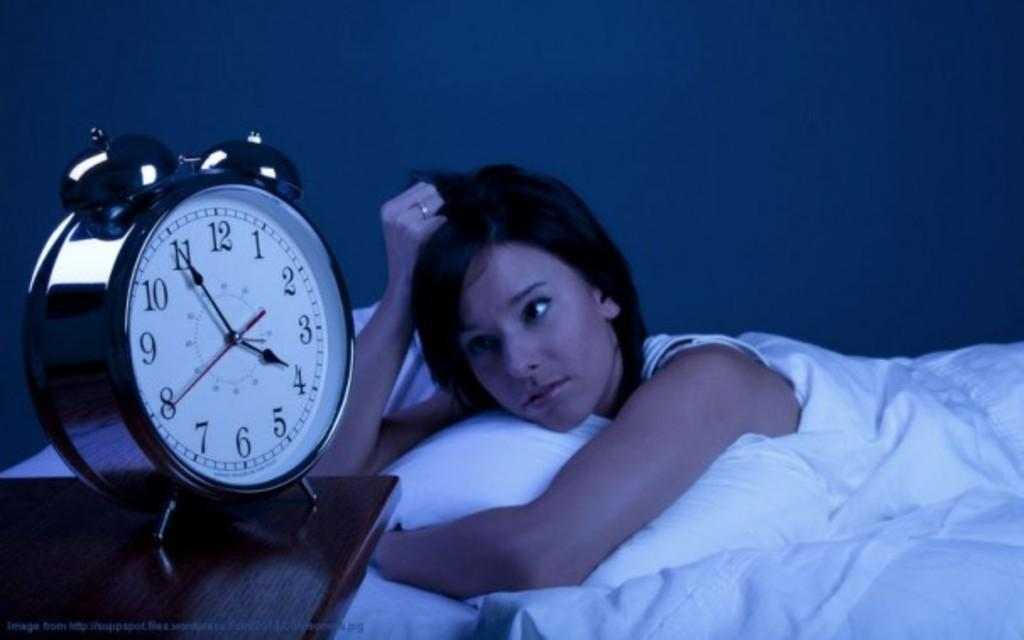Provide a one-sentence caption for the provided image. A woman in bed watches as the clock turns 4. 